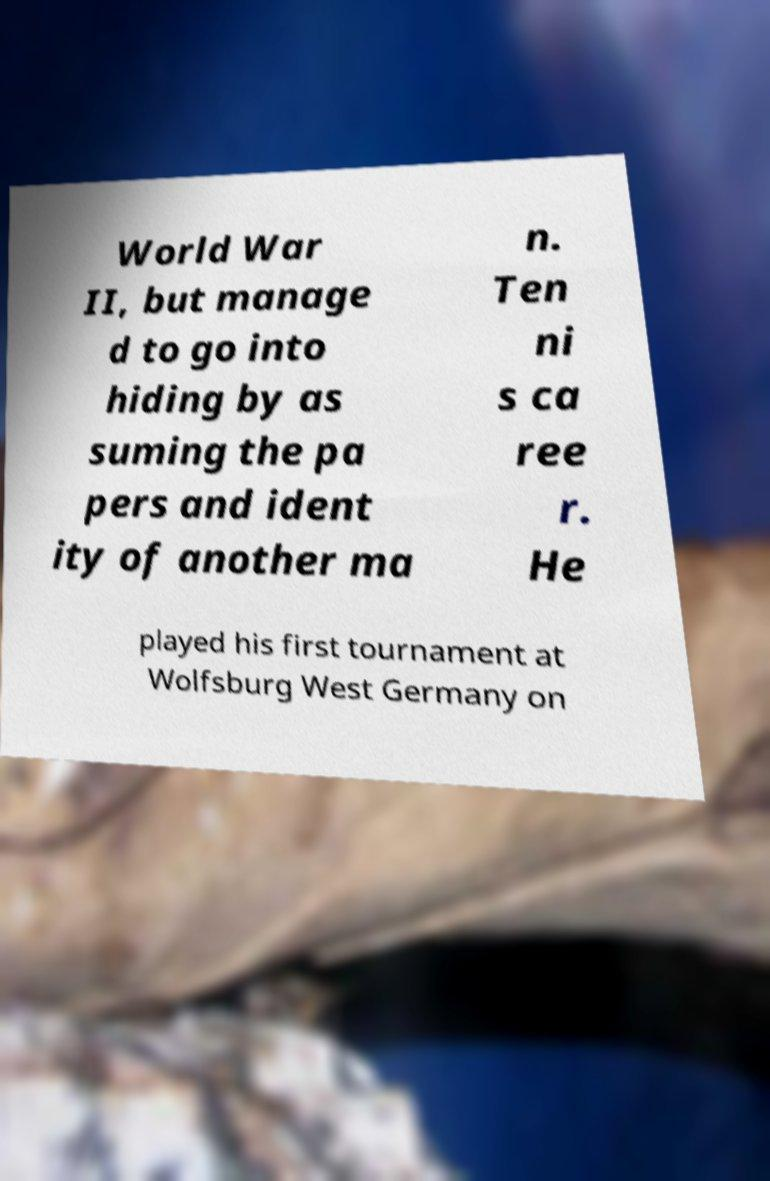Could you assist in decoding the text presented in this image and type it out clearly? World War II, but manage d to go into hiding by as suming the pa pers and ident ity of another ma n. Ten ni s ca ree r. He played his first tournament at Wolfsburg West Germany on 